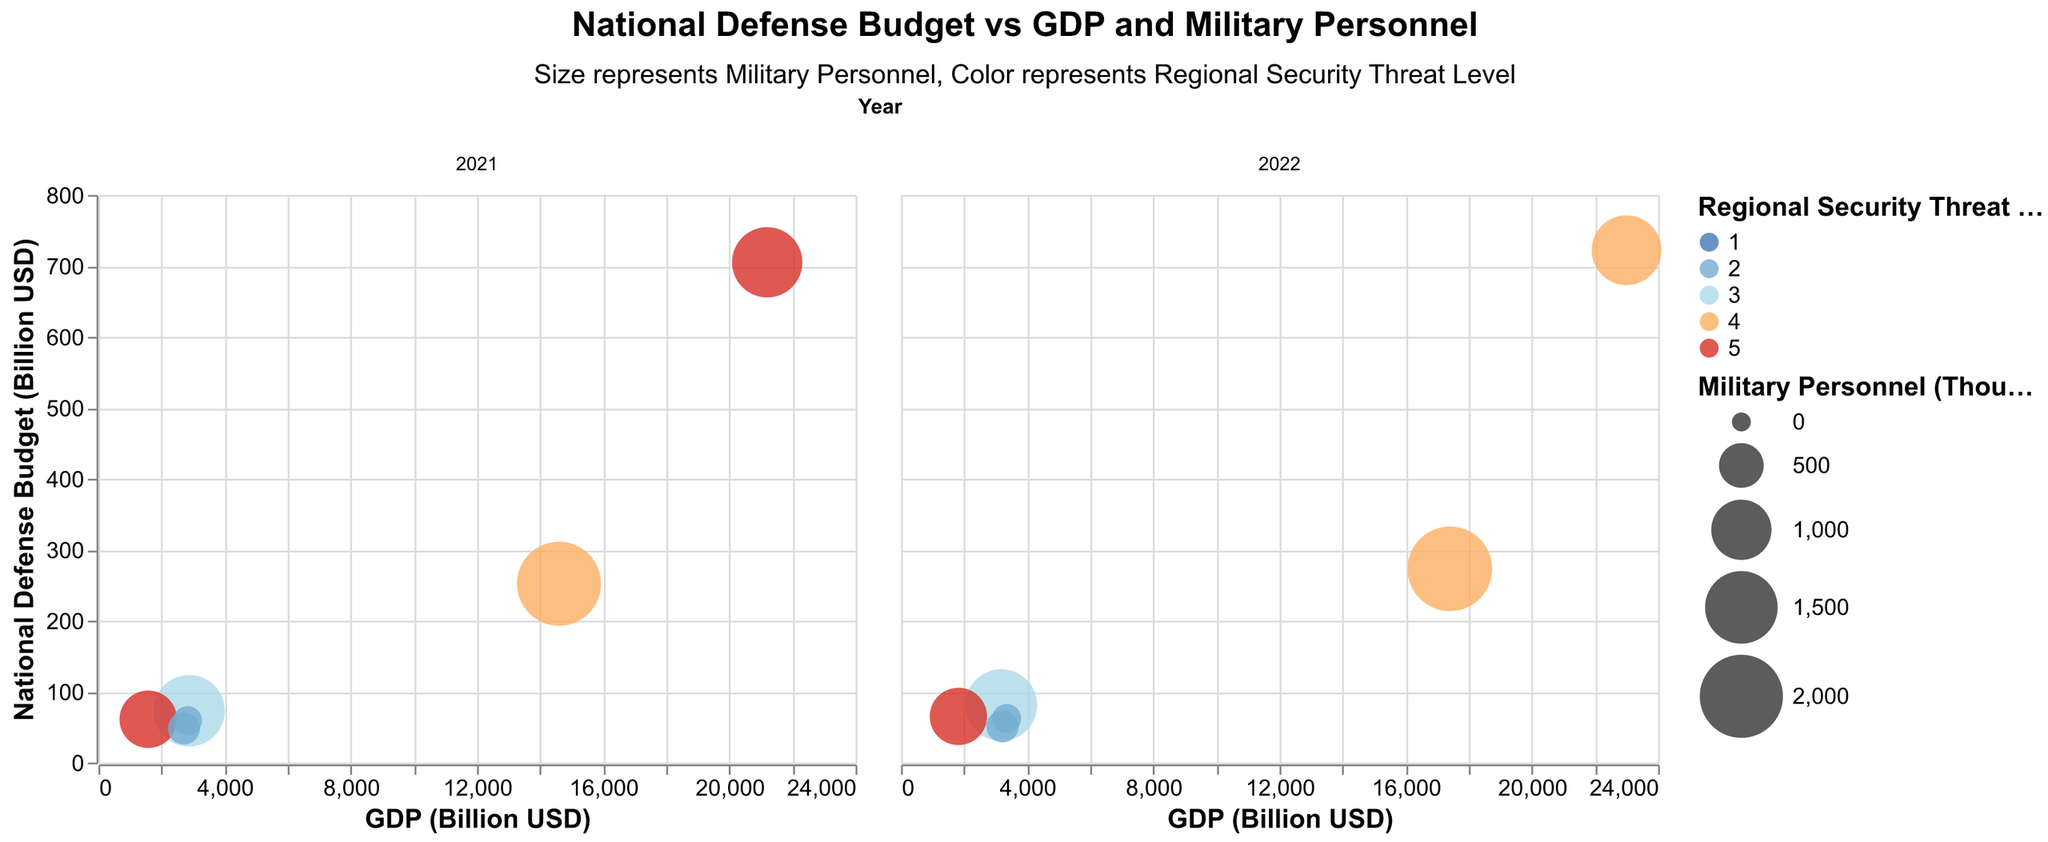How many countries are shown in the plots? To count the countries, we can look at the tooltip data, where each country is listed. The unique countries are the United States, China, India, Russia, United Kingdom, and France.
Answer: 6 Which country has the highest National Defense Budget in 2021? We need to look at the 2021 subplot and compare the y-axis values for each country. The United States has the highest National Defense Budget with 705 Billion USD.
Answer: United States What is the Regional Security Threat Level of Russia in 2022? Find Russia in the 2022 subplot and look at the bubble's color, which represents the Regional Security Threat Level. The color corresponds to 5.
Answer: 5 Which country has the smallest Military Personnel size in 2022? Review the sizes of the bubbles in the 2022 subplot. The United Kingdom has the smallest bubble, indicating the smallest Military Personnel size of 150 thousand.
Answer: United Kingdom How much did the GDP of China increase from 2021 to 2022? Compare the x-axis values of China from 2021 to 2022. In 2021, China's GDP was 14600 Billion USD, and in 2022, it was 17400 Billion USD. The increase is 17400 - 14600 = 2800 Billion USD.
Answer: 2800 Billion USD Which country had the biggest fall in Regional Security Threat Level from 2021 to 2022? Analyze the color changes of the bubbles from 2021 to 2022. The United States' color changes from 5 to 4, indicating the biggest fall in Regional Security Threat Level by 1.
Answer: United States Is there any country with a higher National Defense Budget but lower Military Personnel in 2022 compared to another country? Compare the National Defense Budget and Military Personnel values between countries in 2022. The United States has a higher National Defense Budget (722 Billion USD) but lower Military Personnel (1376 thousand) compared to China, which has a National Defense Budget of 273 Billion USD and Military Personnel of 2076 thousand.
Answer: Yes, United States compared to China Compare the National Defense Budget of France and the United Kingdom in 2021. Look at the y-axis values for France and the United Kingdom in 2021. France's National Defense Budget is 48 Billion USD, while the United Kingdom's is 59 Billion USD.
Answer: United Kingdom has a higher National Defense Budget than France What is the average Regional Security Threat Level for all countries in 2022? Calculate the average of the Regional Security Threat Levels in 2022. The levels are 4, 4, 3, 5, 2, 2. Sum these and divide by the number of countries (6). (4+4+3+5+2+2)/6 = 20/6 ≈ 3.33
Answer: ≈3.33 